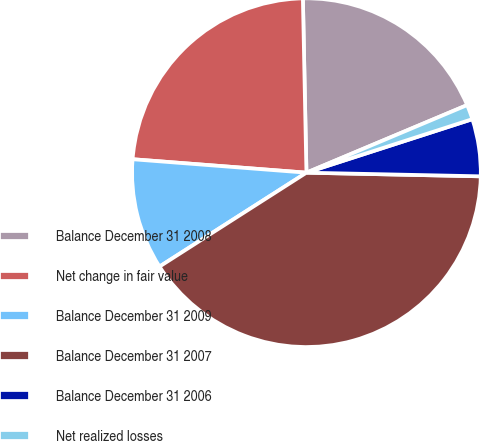Convert chart to OTSL. <chart><loc_0><loc_0><loc_500><loc_500><pie_chart><fcel>Balance December 31 2008<fcel>Net change in fair value<fcel>Balance December 31 2009<fcel>Balance December 31 2007<fcel>Balance December 31 2006<fcel>Net realized losses<nl><fcel>18.99%<fcel>23.45%<fcel>10.28%<fcel>40.62%<fcel>5.3%<fcel>1.37%<nl></chart> 